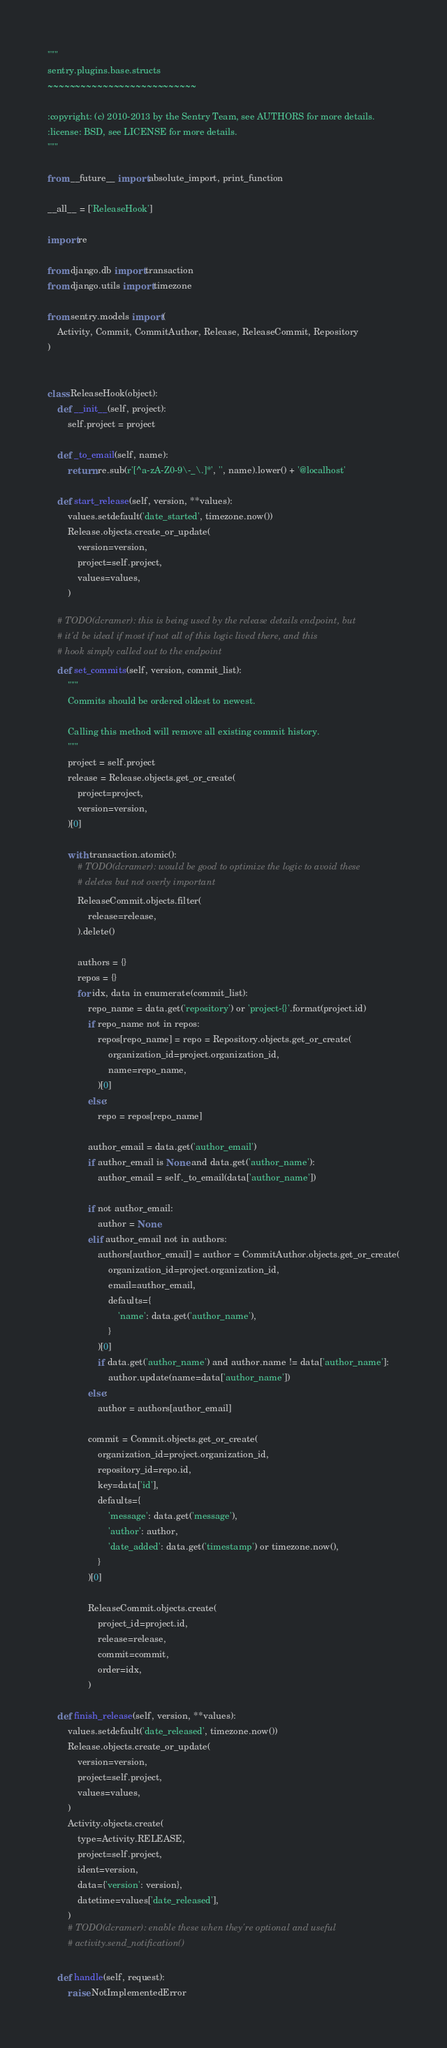Convert code to text. <code><loc_0><loc_0><loc_500><loc_500><_Python_>"""
sentry.plugins.base.structs
~~~~~~~~~~~~~~~~~~~~~~~~~~~

:copyright: (c) 2010-2013 by the Sentry Team, see AUTHORS for more details.
:license: BSD, see LICENSE for more details.
"""

from __future__ import absolute_import, print_function

__all__ = ['ReleaseHook']

import re

from django.db import transaction
from django.utils import timezone

from sentry.models import (
    Activity, Commit, CommitAuthor, Release, ReleaseCommit, Repository
)


class ReleaseHook(object):
    def __init__(self, project):
        self.project = project

    def _to_email(self, name):
        return re.sub(r'[^a-zA-Z0-9\-_\.]*', '', name).lower() + '@localhost'

    def start_release(self, version, **values):
        values.setdefault('date_started', timezone.now())
        Release.objects.create_or_update(
            version=version,
            project=self.project,
            values=values,
        )

    # TODO(dcramer): this is being used by the release details endpoint, but
    # it'd be ideal if most if not all of this logic lived there, and this
    # hook simply called out to the endpoint
    def set_commits(self, version, commit_list):
        """
        Commits should be ordered oldest to newest.

        Calling this method will remove all existing commit history.
        """
        project = self.project
        release = Release.objects.get_or_create(
            project=project,
            version=version,
        )[0]

        with transaction.atomic():
            # TODO(dcramer): would be good to optimize the logic to avoid these
            # deletes but not overly important
            ReleaseCommit.objects.filter(
                release=release,
            ).delete()

            authors = {}
            repos = {}
            for idx, data in enumerate(commit_list):
                repo_name = data.get('repository') or 'project-{}'.format(project.id)
                if repo_name not in repos:
                    repos[repo_name] = repo = Repository.objects.get_or_create(
                        organization_id=project.organization_id,
                        name=repo_name,
                    )[0]
                else:
                    repo = repos[repo_name]

                author_email = data.get('author_email')
                if author_email is None and data.get('author_name'):
                    author_email = self._to_email(data['author_name'])

                if not author_email:
                    author = None
                elif author_email not in authors:
                    authors[author_email] = author = CommitAuthor.objects.get_or_create(
                        organization_id=project.organization_id,
                        email=author_email,
                        defaults={
                            'name': data.get('author_name'),
                        }
                    )[0]
                    if data.get('author_name') and author.name != data['author_name']:
                        author.update(name=data['author_name'])
                else:
                    author = authors[author_email]

                commit = Commit.objects.get_or_create(
                    organization_id=project.organization_id,
                    repository_id=repo.id,
                    key=data['id'],
                    defaults={
                        'message': data.get('message'),
                        'author': author,
                        'date_added': data.get('timestamp') or timezone.now(),
                    }
                )[0]

                ReleaseCommit.objects.create(
                    project_id=project.id,
                    release=release,
                    commit=commit,
                    order=idx,
                )

    def finish_release(self, version, **values):
        values.setdefault('date_released', timezone.now())
        Release.objects.create_or_update(
            version=version,
            project=self.project,
            values=values,
        )
        Activity.objects.create(
            type=Activity.RELEASE,
            project=self.project,
            ident=version,
            data={'version': version},
            datetime=values['date_released'],
        )
        # TODO(dcramer): enable these when they're optional and useful
        # activity.send_notification()

    def handle(self, request):
        raise NotImplementedError
</code> 